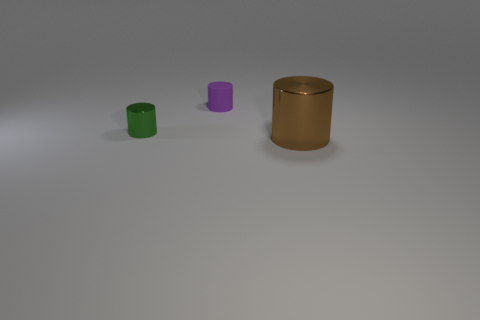How many shiny cylinders are both to the left of the tiny purple object and right of the rubber cylinder?
Keep it short and to the point. 0. How many shiny objects are small blue cylinders or big things?
Provide a short and direct response. 1. There is a cylinder that is in front of the metal thing left of the metallic thing that is right of the tiny green thing; what is it made of?
Offer a very short reply. Metal. There is a cylinder in front of the metal thing behind the big brown object; what is its material?
Keep it short and to the point. Metal. There is a metallic cylinder that is behind the large cylinder; is it the same size as the shiny cylinder to the right of the tiny metallic cylinder?
Give a very brief answer. No. Is there anything else that is made of the same material as the purple object?
Your answer should be compact. No. How many small things are either brown cylinders or metallic spheres?
Give a very brief answer. 0. How many objects are either objects that are on the left side of the large brown object or big objects?
Give a very brief answer. 3. Do the tiny metallic cylinder and the matte cylinder have the same color?
Give a very brief answer. No. How many other things are there of the same shape as the large brown thing?
Your answer should be compact. 2. 